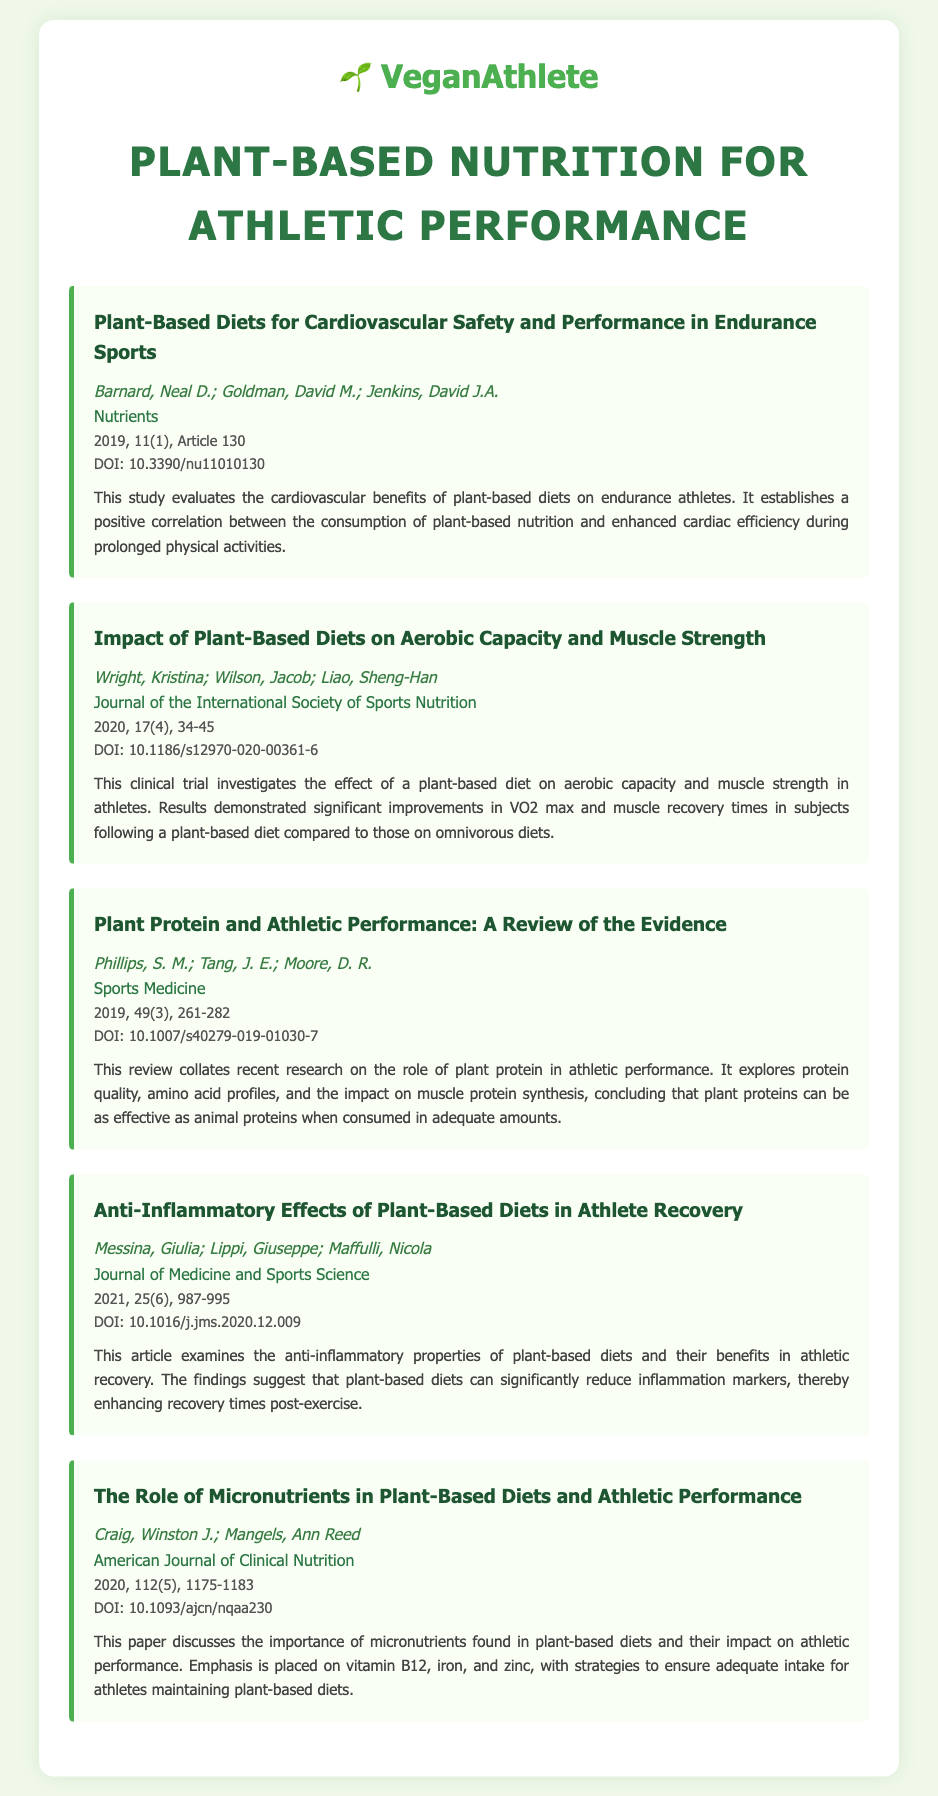what is the title of the first article? The title of the first article is mentioned at the top of the first bibliography item.
Answer: Plant-Based Diets for Cardiovascular Safety and Performance in Endurance Sports who are the authors of the third article? The authors of the third article are listed right below the title in the bibliography item.
Answer: Phillips, S. M.; Tang, J. E.; Moore, D. R what is the volume number of the journal where the fourth article was published? The volume number is included in the details section of the bibliography item for the fourth article.
Answer: 25 how many articles in the bibliography discuss athlete recovery? This requires counting the articles that mention benefits related to recovery.
Answer: 1 what is the DOI of the second article? The DOI is provided in the details section of the second bibliography item.
Answer: 10.1186/s12970-020-00361-6 which journal published the article about the role of micronutrients? The journal name is indicated in the bibliography item associated with that specific article.
Answer: American Journal of Clinical Nutrition what year was the last article published? The publication year is found within the details section of the last bibliography item.
Answer: 2020 how many authors contributed to the first article? The authors of the first article can be counted from the list provided in that section.
Answer: 3 